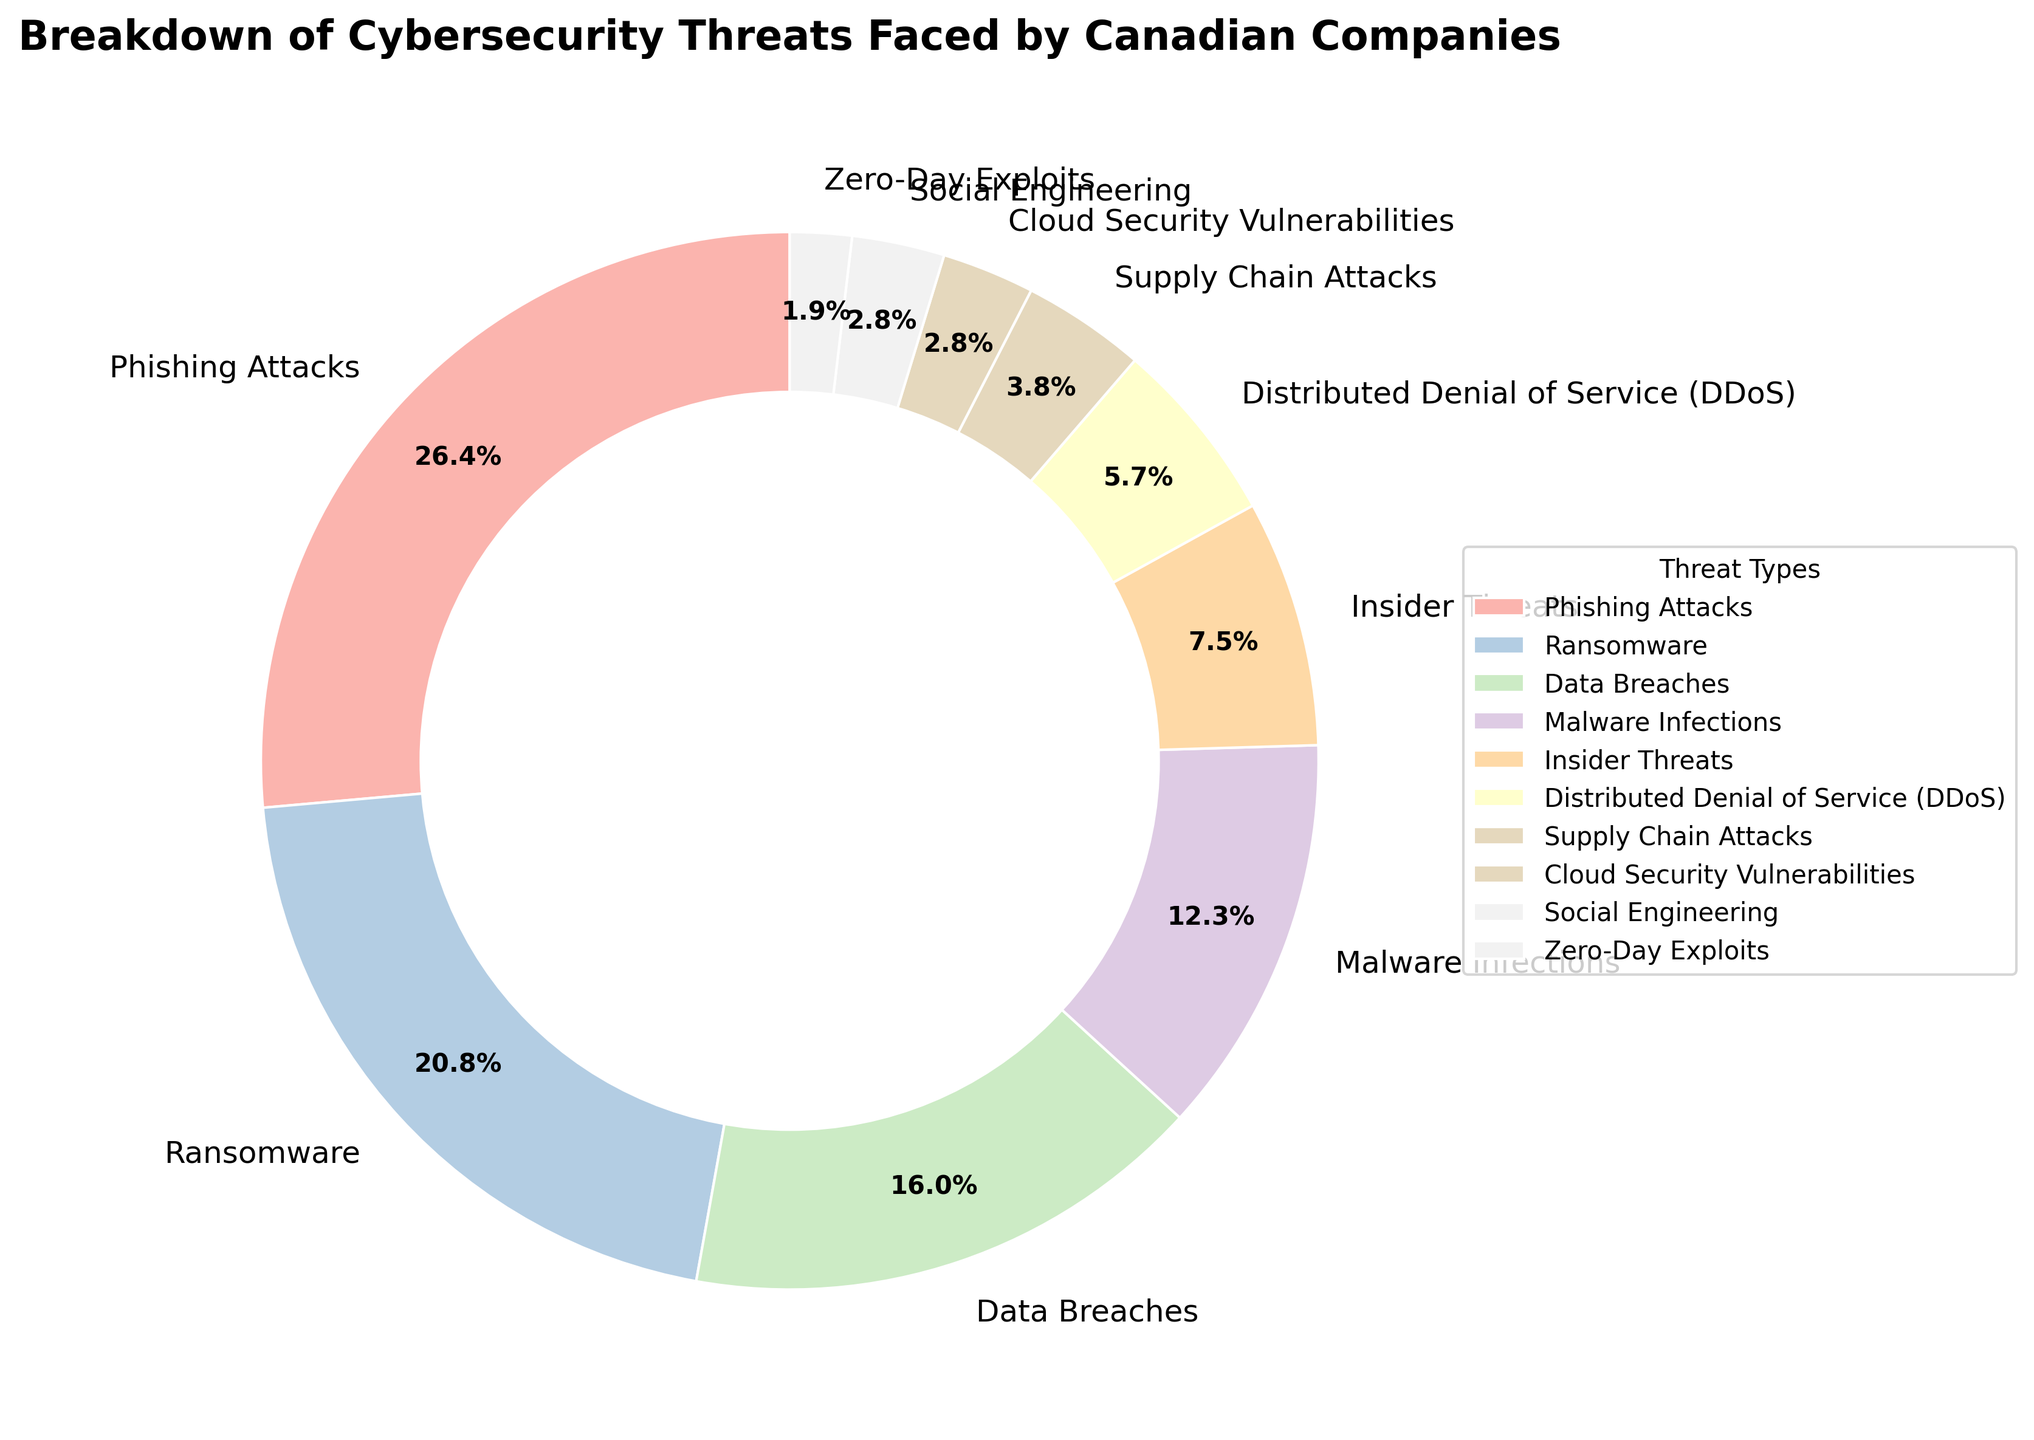What percentage of cybersecurity threats are due to Phishing Attacks and Ransomware combined? To find the combined percentage, add the percentages of Phishing Attacks (28%) and Ransomware (22%). So, 28 + 22 = 50.
Answer: 50% Which is the least common cybersecurity threat faced by Canadian companies? From the figure, the threat type with the smallest percentage is Zero-Day Exploits, which is marked as 2%.
Answer: Zero-Day Exploits Which threat type causes more issues: Data Breaches or Malware Infections? By comparing the percentages, Data Breaches account for 17% while Malware Infections account for 13%. Since 17% is greater than 13%, Data Breaches cause more issues.
Answer: Data Breaches How does the percentage of Insider Threats compare to that of Distributed Denial of Service (DDoS)? Insider Threats account for 8% and DDoS accounts for 6%. Comparing the two, 8% is greater than 6%.
Answer: Insider Threats > DDoS What is the total percentage of lesser-known threats (Supply Chain Attacks, Cloud Security Vulnerabilities, Social Engineering, Zero-Day Exploits)? To find the total, add the percentages: 4 (Supply Chain Attacks) + 3 (Cloud Security Vulnerabilities) + 3 (Social Engineering) + 2 (Zero-Day Exploits) = 12.
Answer: 12% Arrange the top three cybersecurity threats in descending order. The top three threats by percentage are Phishing Attacks (28%), Ransomware (22%), and Data Breaches (17%). Arranging in descending order: Phishing Attacks, Ransomware, Data Breaches.
Answer: Phishing Attacks, Ransomware, Data Breaches Which has a smaller percentage, Malware Infections or Insider Threats, and what is the difference between these two percentages? Malware Infections account for 13% and Insider Threats account for 8%. Since 8% is smaller than 13%, Insider Threats have a smaller percentage. The difference is 13 - 8 = 5%.
Answer: Insider Threats; 5% What is the average percentage of all listed cybersecurity threats? To calculate the average, sum all the percentages: 28 + 22 + 17 + 13 + 8 + 6 + 4 + 3 + 3 + 2 = 106. Then divide by the number of threat types (10), so 106/10 = 10.6.
Answer: 10.6% What threat types have the same percentage and what are those percentages? From the figure, Social Engineering and Cloud Security Vulnerabilities both have a percentage of 3%.
Answer: Social Engineering and Cloud Security Vulnerabilities; 3% 